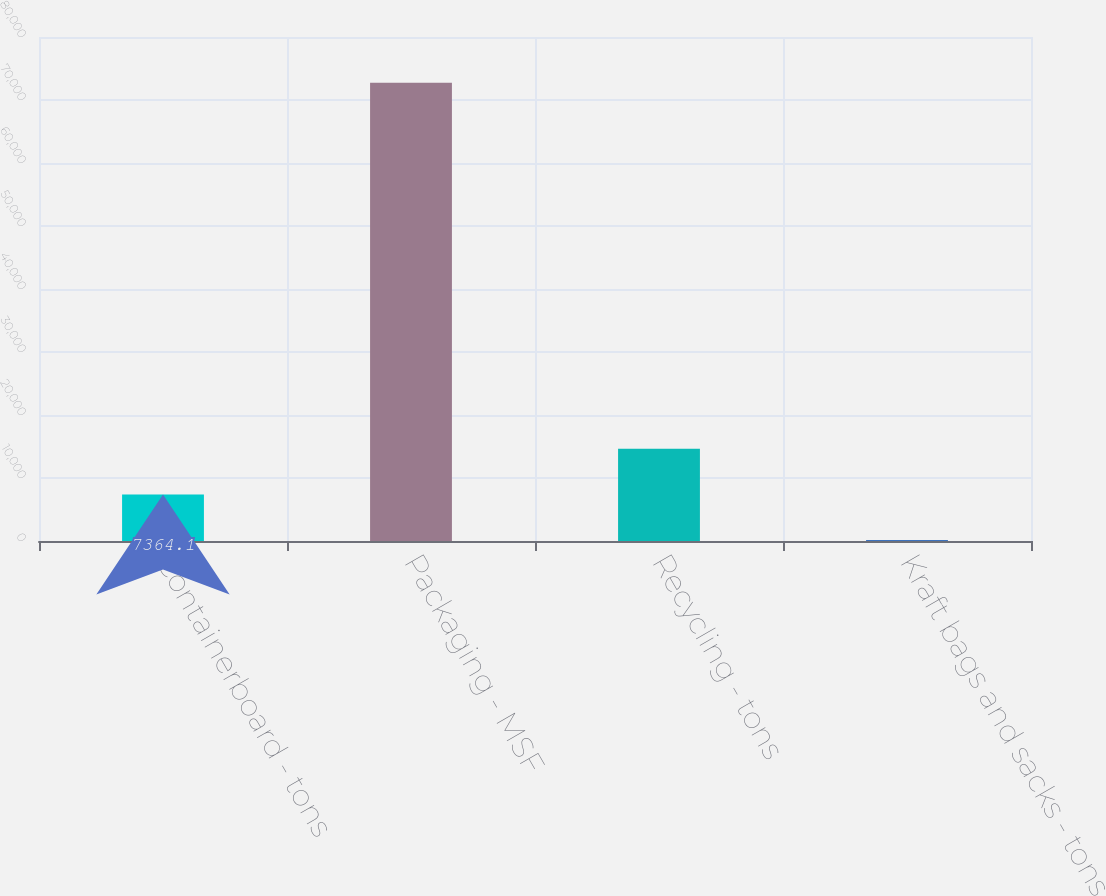Convert chart to OTSL. <chart><loc_0><loc_0><loc_500><loc_500><bar_chart><fcel>Containerboard - tons<fcel>Packaging - MSF<fcel>Recycling - tons<fcel>Kraft bags and sacks - tons<nl><fcel>7364.1<fcel>72741<fcel>14628.2<fcel>100<nl></chart> 